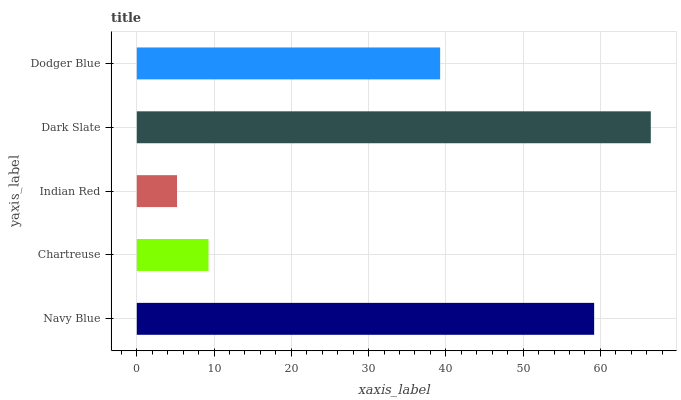Is Indian Red the minimum?
Answer yes or no. Yes. Is Dark Slate the maximum?
Answer yes or no. Yes. Is Chartreuse the minimum?
Answer yes or no. No. Is Chartreuse the maximum?
Answer yes or no. No. Is Navy Blue greater than Chartreuse?
Answer yes or no. Yes. Is Chartreuse less than Navy Blue?
Answer yes or no. Yes. Is Chartreuse greater than Navy Blue?
Answer yes or no. No. Is Navy Blue less than Chartreuse?
Answer yes or no. No. Is Dodger Blue the high median?
Answer yes or no. Yes. Is Dodger Blue the low median?
Answer yes or no. Yes. Is Chartreuse the high median?
Answer yes or no. No. Is Navy Blue the low median?
Answer yes or no. No. 